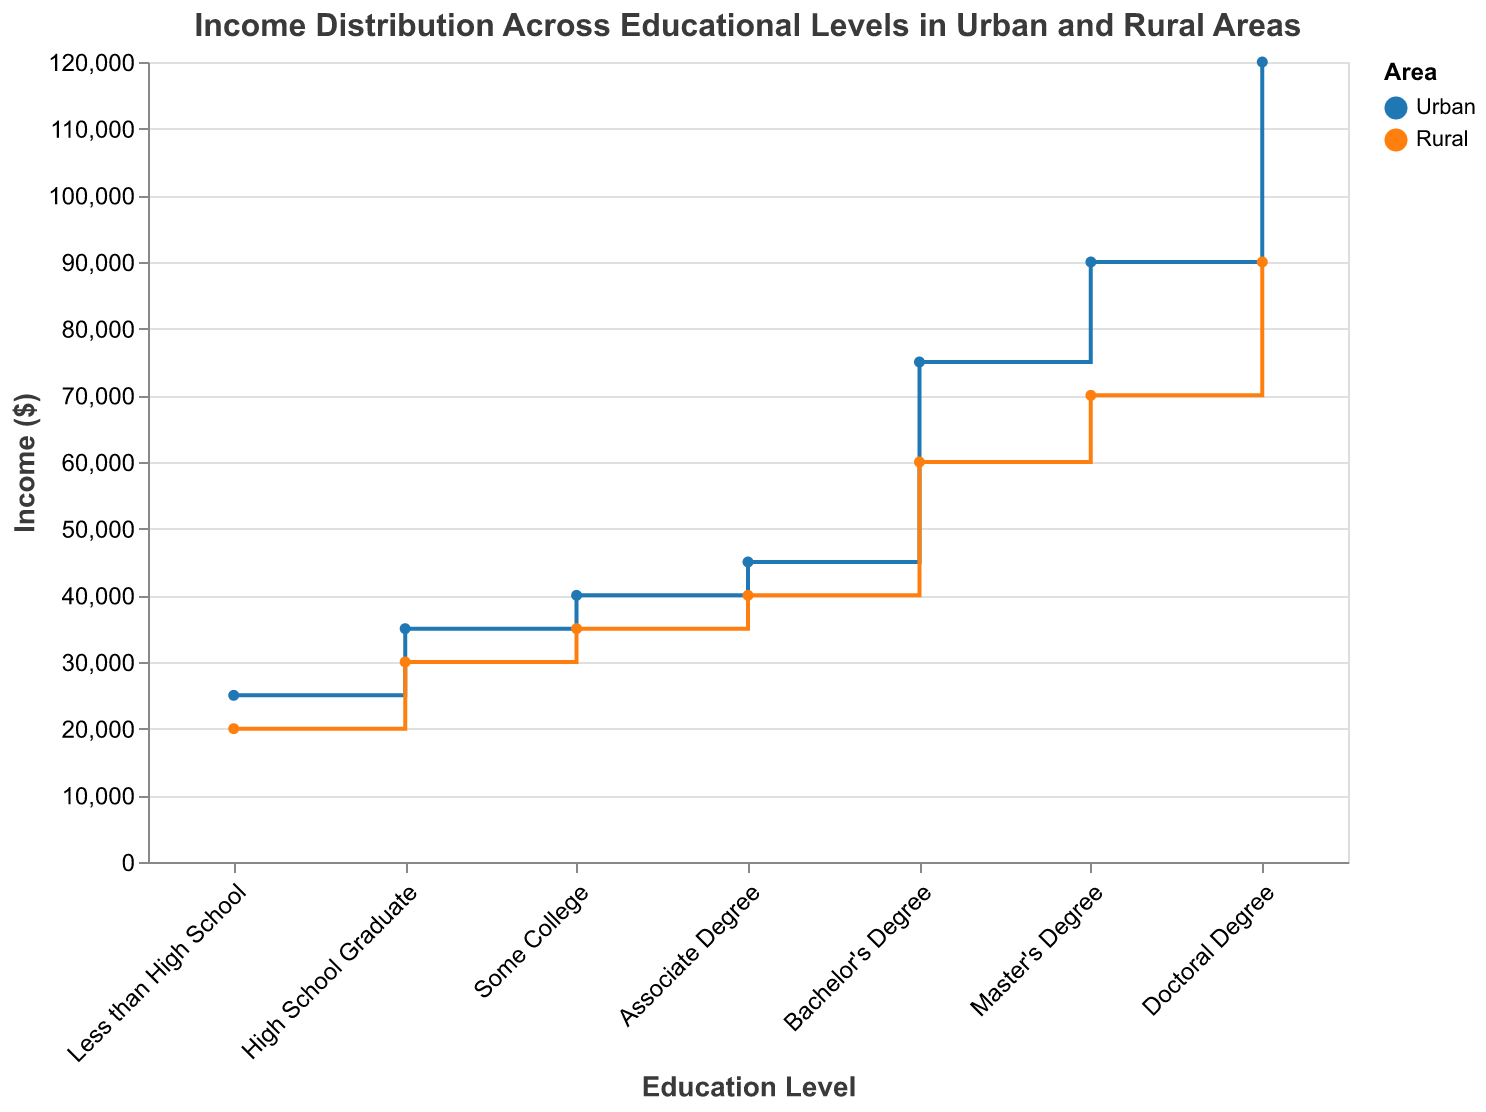What's the title of the figure? The title of the figure is text that appears at the top, centered, and describes what the figure is about. Here, the title indicates the figure is about income distribution across educational levels in urban and rural areas.
Answer: Income Distribution Across Educational Levels in Urban and Rural Areas How many data points are depicted for Rural areas? Each educational level has a corresponding income data point for the Rural area in the figure. There are seven educational levels shown.
Answer: 7 What is the income for someone with an Associate Degree in Urban areas? Locate the point corresponding to "Associate Degree" on the x-axis and trace it vertically to the income value for the Urban area color (blue).
Answer: 45000 Which area has a higher income for Master's Degree holders? Compare the income values for the Master's Degree between Urban (blue) and Rural (orange). The Urban income for Master's Degree holders is 90000, while for Rural, it is 70000.
Answer: Urban What is the difference in income for High School Graduates between Urban and Rural areas? Locate the High School Graduate data points for both Urban and Rural areas. The Urban income is 35000 and the Rural income is 30000. Calculate the difference: 35000 - 30000.
Answer: 5000 Which educational level shows the largest income difference between Urban and Rural areas? Compare the vertical differences (gaps) between the Urban and Rural lines at each educational level. The largest income difference is at the Doctoral Degree level: Urban (120000) - Rural (90000) = 30000.
Answer: Doctoral Degree What is the average income for Urban areas for all educational levels? Sum the Urban incomes for all educational levels and divide by the number of levels: (25000 + 35000 + 40000 + 45000 + 75000 + 90000 + 120000) / 7. Calculations: (25000 + 35000 + 40000 + 45000 + 75000 + 90000 + 120000) = 430000. Average = 430000 / 7.
Answer: 61428.57 At which educational level does the income in Rural areas first reach 40000? Trace the income values for Rural areas until you reach or surpass 40000. This occurs at the "Associate Degree" level.
Answer: Associate Degree How does the income trend change as educational levels increase in Urban areas? Observe the pattern of the increase in income values along the x-axis for Urban areas. The income consistently increases as the educational level increases, showing a positive correlation between education and income.
Answer: Increases In which area does having a Doctoral Degree result in the highest income? Compare the Doctoral Degree income between Rural (orange) and Urban (blue) areas. The income is higher in Urban areas (120000 vs. 90000).
Answer: Urban 